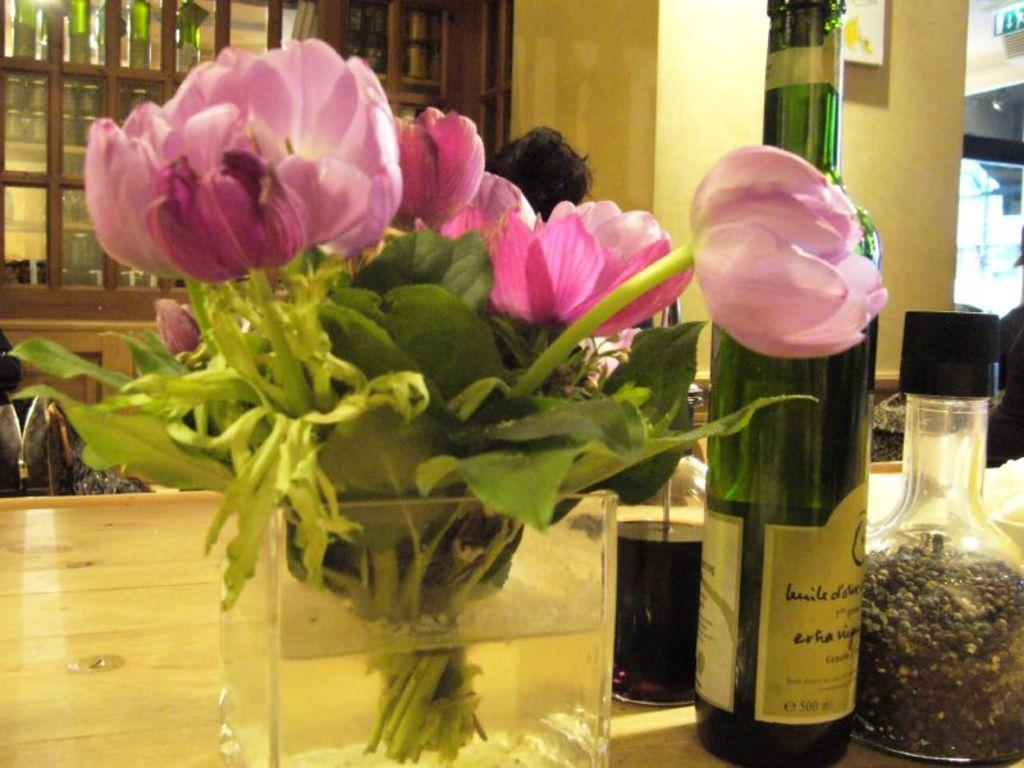What can be seen in the image that is colorful and floral? There is a colorful bouquet in the image. What type of beverage is associated with the wine bottle in the image? The wine bottle in the image is associated with wine, a type of alcoholic beverage. What is used for drinking in the image? There is a glass in the image that can be used for drinking. What type of architectural feature can be seen in the background of the image? There are glass windows in the background of the image. Can you see any hands holding the wine bottle in the image? There are no hands visible in the image, nor is there any indication that someone is holding the wine bottle. Is there any quicksand present in the image? There is no quicksand present in the image; it features a colorful bouquet, a wine bottle, a glass, and glass windows. 